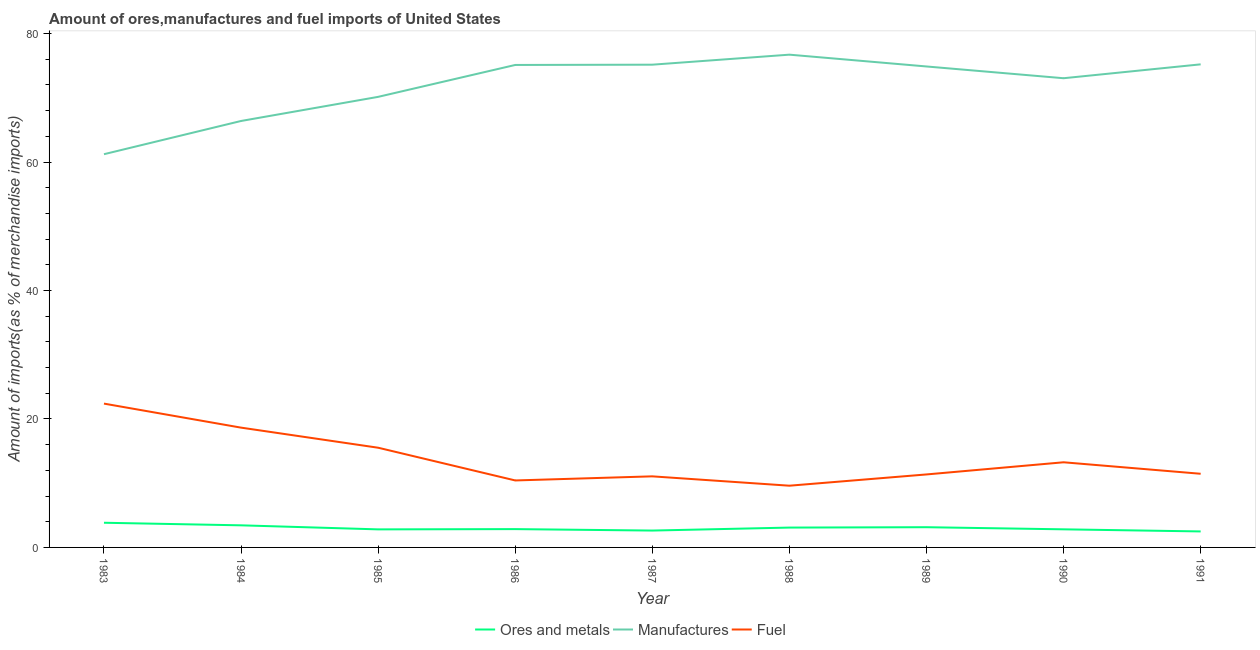What is the percentage of ores and metals imports in 1988?
Ensure brevity in your answer.  3.09. Across all years, what is the maximum percentage of manufactures imports?
Keep it short and to the point. 76.72. Across all years, what is the minimum percentage of fuel imports?
Offer a terse response. 9.61. In which year was the percentage of fuel imports minimum?
Provide a succinct answer. 1988. What is the total percentage of ores and metals imports in the graph?
Provide a succinct answer. 27.12. What is the difference between the percentage of fuel imports in 1984 and that in 1991?
Your response must be concise. 7.18. What is the difference between the percentage of manufactures imports in 1986 and the percentage of ores and metals imports in 1991?
Offer a very short reply. 72.63. What is the average percentage of ores and metals imports per year?
Offer a terse response. 3.01. In the year 1986, what is the difference between the percentage of manufactures imports and percentage of ores and metals imports?
Make the answer very short. 72.26. What is the ratio of the percentage of fuel imports in 1986 to that in 1987?
Keep it short and to the point. 0.94. What is the difference between the highest and the second highest percentage of manufactures imports?
Offer a terse response. 1.51. What is the difference between the highest and the lowest percentage of ores and metals imports?
Your response must be concise. 1.35. Is the percentage of fuel imports strictly greater than the percentage of manufactures imports over the years?
Provide a short and direct response. No. How many lines are there?
Offer a very short reply. 3. Are the values on the major ticks of Y-axis written in scientific E-notation?
Your answer should be compact. No. Does the graph contain grids?
Provide a succinct answer. No. Where does the legend appear in the graph?
Provide a short and direct response. Bottom center. What is the title of the graph?
Keep it short and to the point. Amount of ores,manufactures and fuel imports of United States. Does "Industrial Nitrous Oxide" appear as one of the legend labels in the graph?
Your answer should be very brief. No. What is the label or title of the X-axis?
Offer a very short reply. Year. What is the label or title of the Y-axis?
Your response must be concise. Amount of imports(as % of merchandise imports). What is the Amount of imports(as % of merchandise imports) in Ores and metals in 1983?
Your answer should be compact. 3.84. What is the Amount of imports(as % of merchandise imports) of Manufactures in 1983?
Your response must be concise. 61.22. What is the Amount of imports(as % of merchandise imports) in Fuel in 1983?
Make the answer very short. 22.39. What is the Amount of imports(as % of merchandise imports) of Ores and metals in 1984?
Make the answer very short. 3.44. What is the Amount of imports(as % of merchandise imports) of Manufactures in 1984?
Give a very brief answer. 66.39. What is the Amount of imports(as % of merchandise imports) of Fuel in 1984?
Give a very brief answer. 18.65. What is the Amount of imports(as % of merchandise imports) of Ores and metals in 1985?
Provide a succinct answer. 2.81. What is the Amount of imports(as % of merchandise imports) in Manufactures in 1985?
Your response must be concise. 70.15. What is the Amount of imports(as % of merchandise imports) in Fuel in 1985?
Keep it short and to the point. 15.52. What is the Amount of imports(as % of merchandise imports) in Ores and metals in 1986?
Ensure brevity in your answer.  2.85. What is the Amount of imports(as % of merchandise imports) of Manufactures in 1986?
Make the answer very short. 75.12. What is the Amount of imports(as % of merchandise imports) in Fuel in 1986?
Offer a terse response. 10.43. What is the Amount of imports(as % of merchandise imports) in Ores and metals in 1987?
Provide a succinct answer. 2.63. What is the Amount of imports(as % of merchandise imports) in Manufactures in 1987?
Your answer should be very brief. 75.16. What is the Amount of imports(as % of merchandise imports) of Fuel in 1987?
Ensure brevity in your answer.  11.07. What is the Amount of imports(as % of merchandise imports) of Ores and metals in 1988?
Make the answer very short. 3.09. What is the Amount of imports(as % of merchandise imports) of Manufactures in 1988?
Offer a very short reply. 76.72. What is the Amount of imports(as % of merchandise imports) in Fuel in 1988?
Offer a very short reply. 9.61. What is the Amount of imports(as % of merchandise imports) of Ores and metals in 1989?
Ensure brevity in your answer.  3.15. What is the Amount of imports(as % of merchandise imports) of Manufactures in 1989?
Give a very brief answer. 74.88. What is the Amount of imports(as % of merchandise imports) in Fuel in 1989?
Offer a terse response. 11.36. What is the Amount of imports(as % of merchandise imports) in Ores and metals in 1990?
Provide a short and direct response. 2.82. What is the Amount of imports(as % of merchandise imports) in Manufactures in 1990?
Provide a short and direct response. 73.05. What is the Amount of imports(as % of merchandise imports) of Fuel in 1990?
Offer a very short reply. 13.26. What is the Amount of imports(as % of merchandise imports) in Ores and metals in 1991?
Make the answer very short. 2.49. What is the Amount of imports(as % of merchandise imports) in Manufactures in 1991?
Provide a short and direct response. 75.21. What is the Amount of imports(as % of merchandise imports) in Fuel in 1991?
Provide a short and direct response. 11.47. Across all years, what is the maximum Amount of imports(as % of merchandise imports) of Ores and metals?
Give a very brief answer. 3.84. Across all years, what is the maximum Amount of imports(as % of merchandise imports) of Manufactures?
Offer a very short reply. 76.72. Across all years, what is the maximum Amount of imports(as % of merchandise imports) in Fuel?
Keep it short and to the point. 22.39. Across all years, what is the minimum Amount of imports(as % of merchandise imports) in Ores and metals?
Offer a very short reply. 2.49. Across all years, what is the minimum Amount of imports(as % of merchandise imports) of Manufactures?
Your answer should be compact. 61.22. Across all years, what is the minimum Amount of imports(as % of merchandise imports) in Fuel?
Offer a very short reply. 9.61. What is the total Amount of imports(as % of merchandise imports) in Ores and metals in the graph?
Make the answer very short. 27.12. What is the total Amount of imports(as % of merchandise imports) of Manufactures in the graph?
Keep it short and to the point. 647.9. What is the total Amount of imports(as % of merchandise imports) in Fuel in the graph?
Your response must be concise. 123.75. What is the difference between the Amount of imports(as % of merchandise imports) in Ores and metals in 1983 and that in 1984?
Your answer should be very brief. 0.4. What is the difference between the Amount of imports(as % of merchandise imports) of Manufactures in 1983 and that in 1984?
Ensure brevity in your answer.  -5.17. What is the difference between the Amount of imports(as % of merchandise imports) in Fuel in 1983 and that in 1984?
Provide a short and direct response. 3.74. What is the difference between the Amount of imports(as % of merchandise imports) of Ores and metals in 1983 and that in 1985?
Ensure brevity in your answer.  1.03. What is the difference between the Amount of imports(as % of merchandise imports) in Manufactures in 1983 and that in 1985?
Keep it short and to the point. -8.93. What is the difference between the Amount of imports(as % of merchandise imports) in Fuel in 1983 and that in 1985?
Provide a succinct answer. 6.87. What is the difference between the Amount of imports(as % of merchandise imports) in Ores and metals in 1983 and that in 1986?
Provide a short and direct response. 0.99. What is the difference between the Amount of imports(as % of merchandise imports) in Manufactures in 1983 and that in 1986?
Give a very brief answer. -13.89. What is the difference between the Amount of imports(as % of merchandise imports) in Fuel in 1983 and that in 1986?
Give a very brief answer. 11.96. What is the difference between the Amount of imports(as % of merchandise imports) of Ores and metals in 1983 and that in 1987?
Make the answer very short. 1.21. What is the difference between the Amount of imports(as % of merchandise imports) in Manufactures in 1983 and that in 1987?
Offer a very short reply. -13.94. What is the difference between the Amount of imports(as % of merchandise imports) of Fuel in 1983 and that in 1987?
Make the answer very short. 11.32. What is the difference between the Amount of imports(as % of merchandise imports) of Ores and metals in 1983 and that in 1988?
Offer a very short reply. 0.75. What is the difference between the Amount of imports(as % of merchandise imports) in Manufactures in 1983 and that in 1988?
Offer a very short reply. -15.5. What is the difference between the Amount of imports(as % of merchandise imports) in Fuel in 1983 and that in 1988?
Offer a terse response. 12.78. What is the difference between the Amount of imports(as % of merchandise imports) in Ores and metals in 1983 and that in 1989?
Provide a succinct answer. 0.69. What is the difference between the Amount of imports(as % of merchandise imports) of Manufactures in 1983 and that in 1989?
Your answer should be very brief. -13.66. What is the difference between the Amount of imports(as % of merchandise imports) in Fuel in 1983 and that in 1989?
Provide a short and direct response. 11.03. What is the difference between the Amount of imports(as % of merchandise imports) of Ores and metals in 1983 and that in 1990?
Keep it short and to the point. 1.02. What is the difference between the Amount of imports(as % of merchandise imports) in Manufactures in 1983 and that in 1990?
Provide a short and direct response. -11.83. What is the difference between the Amount of imports(as % of merchandise imports) in Fuel in 1983 and that in 1990?
Offer a very short reply. 9.13. What is the difference between the Amount of imports(as % of merchandise imports) of Ores and metals in 1983 and that in 1991?
Offer a very short reply. 1.35. What is the difference between the Amount of imports(as % of merchandise imports) of Manufactures in 1983 and that in 1991?
Make the answer very short. -13.99. What is the difference between the Amount of imports(as % of merchandise imports) in Fuel in 1983 and that in 1991?
Make the answer very short. 10.92. What is the difference between the Amount of imports(as % of merchandise imports) in Ores and metals in 1984 and that in 1985?
Give a very brief answer. 0.63. What is the difference between the Amount of imports(as % of merchandise imports) of Manufactures in 1984 and that in 1985?
Your answer should be very brief. -3.76. What is the difference between the Amount of imports(as % of merchandise imports) of Fuel in 1984 and that in 1985?
Offer a very short reply. 3.13. What is the difference between the Amount of imports(as % of merchandise imports) in Ores and metals in 1984 and that in 1986?
Ensure brevity in your answer.  0.59. What is the difference between the Amount of imports(as % of merchandise imports) of Manufactures in 1984 and that in 1986?
Provide a short and direct response. -8.72. What is the difference between the Amount of imports(as % of merchandise imports) in Fuel in 1984 and that in 1986?
Offer a very short reply. 8.22. What is the difference between the Amount of imports(as % of merchandise imports) in Ores and metals in 1984 and that in 1987?
Offer a very short reply. 0.81. What is the difference between the Amount of imports(as % of merchandise imports) in Manufactures in 1984 and that in 1987?
Your answer should be compact. -8.76. What is the difference between the Amount of imports(as % of merchandise imports) in Fuel in 1984 and that in 1987?
Provide a short and direct response. 7.58. What is the difference between the Amount of imports(as % of merchandise imports) of Ores and metals in 1984 and that in 1988?
Provide a short and direct response. 0.35. What is the difference between the Amount of imports(as % of merchandise imports) in Manufactures in 1984 and that in 1988?
Your answer should be compact. -10.32. What is the difference between the Amount of imports(as % of merchandise imports) of Fuel in 1984 and that in 1988?
Your answer should be compact. 9.04. What is the difference between the Amount of imports(as % of merchandise imports) of Ores and metals in 1984 and that in 1989?
Your answer should be very brief. 0.29. What is the difference between the Amount of imports(as % of merchandise imports) of Manufactures in 1984 and that in 1989?
Your answer should be compact. -8.49. What is the difference between the Amount of imports(as % of merchandise imports) of Fuel in 1984 and that in 1989?
Offer a very short reply. 7.29. What is the difference between the Amount of imports(as % of merchandise imports) in Ores and metals in 1984 and that in 1990?
Give a very brief answer. 0.62. What is the difference between the Amount of imports(as % of merchandise imports) in Manufactures in 1984 and that in 1990?
Your answer should be very brief. -6.66. What is the difference between the Amount of imports(as % of merchandise imports) of Fuel in 1984 and that in 1990?
Provide a short and direct response. 5.39. What is the difference between the Amount of imports(as % of merchandise imports) in Ores and metals in 1984 and that in 1991?
Provide a succinct answer. 0.95. What is the difference between the Amount of imports(as % of merchandise imports) in Manufactures in 1984 and that in 1991?
Offer a terse response. -8.82. What is the difference between the Amount of imports(as % of merchandise imports) of Fuel in 1984 and that in 1991?
Provide a succinct answer. 7.18. What is the difference between the Amount of imports(as % of merchandise imports) in Ores and metals in 1985 and that in 1986?
Offer a terse response. -0.04. What is the difference between the Amount of imports(as % of merchandise imports) in Manufactures in 1985 and that in 1986?
Make the answer very short. -4.97. What is the difference between the Amount of imports(as % of merchandise imports) in Fuel in 1985 and that in 1986?
Your response must be concise. 5.1. What is the difference between the Amount of imports(as % of merchandise imports) in Ores and metals in 1985 and that in 1987?
Provide a short and direct response. 0.19. What is the difference between the Amount of imports(as % of merchandise imports) of Manufactures in 1985 and that in 1987?
Provide a succinct answer. -5.01. What is the difference between the Amount of imports(as % of merchandise imports) in Fuel in 1985 and that in 1987?
Your answer should be very brief. 4.46. What is the difference between the Amount of imports(as % of merchandise imports) of Ores and metals in 1985 and that in 1988?
Provide a succinct answer. -0.28. What is the difference between the Amount of imports(as % of merchandise imports) of Manufactures in 1985 and that in 1988?
Your answer should be compact. -6.57. What is the difference between the Amount of imports(as % of merchandise imports) of Fuel in 1985 and that in 1988?
Offer a terse response. 5.91. What is the difference between the Amount of imports(as % of merchandise imports) of Ores and metals in 1985 and that in 1989?
Keep it short and to the point. -0.34. What is the difference between the Amount of imports(as % of merchandise imports) of Manufactures in 1985 and that in 1989?
Offer a very short reply. -4.73. What is the difference between the Amount of imports(as % of merchandise imports) of Fuel in 1985 and that in 1989?
Your answer should be very brief. 4.16. What is the difference between the Amount of imports(as % of merchandise imports) of Ores and metals in 1985 and that in 1990?
Ensure brevity in your answer.  -0.01. What is the difference between the Amount of imports(as % of merchandise imports) in Manufactures in 1985 and that in 1990?
Offer a terse response. -2.9. What is the difference between the Amount of imports(as % of merchandise imports) in Fuel in 1985 and that in 1990?
Your answer should be compact. 2.27. What is the difference between the Amount of imports(as % of merchandise imports) of Ores and metals in 1985 and that in 1991?
Make the answer very short. 0.32. What is the difference between the Amount of imports(as % of merchandise imports) in Manufactures in 1985 and that in 1991?
Provide a succinct answer. -5.06. What is the difference between the Amount of imports(as % of merchandise imports) in Fuel in 1985 and that in 1991?
Your response must be concise. 4.06. What is the difference between the Amount of imports(as % of merchandise imports) of Ores and metals in 1986 and that in 1987?
Offer a very short reply. 0.23. What is the difference between the Amount of imports(as % of merchandise imports) in Manufactures in 1986 and that in 1987?
Give a very brief answer. -0.04. What is the difference between the Amount of imports(as % of merchandise imports) in Fuel in 1986 and that in 1987?
Offer a terse response. -0.64. What is the difference between the Amount of imports(as % of merchandise imports) of Ores and metals in 1986 and that in 1988?
Your answer should be very brief. -0.24. What is the difference between the Amount of imports(as % of merchandise imports) of Manufactures in 1986 and that in 1988?
Keep it short and to the point. -1.6. What is the difference between the Amount of imports(as % of merchandise imports) in Fuel in 1986 and that in 1988?
Your response must be concise. 0.82. What is the difference between the Amount of imports(as % of merchandise imports) in Ores and metals in 1986 and that in 1989?
Offer a terse response. -0.3. What is the difference between the Amount of imports(as % of merchandise imports) of Manufactures in 1986 and that in 1989?
Ensure brevity in your answer.  0.24. What is the difference between the Amount of imports(as % of merchandise imports) in Fuel in 1986 and that in 1989?
Offer a very short reply. -0.94. What is the difference between the Amount of imports(as % of merchandise imports) in Ores and metals in 1986 and that in 1990?
Give a very brief answer. 0.03. What is the difference between the Amount of imports(as % of merchandise imports) of Manufactures in 1986 and that in 1990?
Provide a succinct answer. 2.07. What is the difference between the Amount of imports(as % of merchandise imports) in Fuel in 1986 and that in 1990?
Offer a terse response. -2.83. What is the difference between the Amount of imports(as % of merchandise imports) of Ores and metals in 1986 and that in 1991?
Offer a very short reply. 0.36. What is the difference between the Amount of imports(as % of merchandise imports) in Manufactures in 1986 and that in 1991?
Keep it short and to the point. -0.1. What is the difference between the Amount of imports(as % of merchandise imports) in Fuel in 1986 and that in 1991?
Offer a terse response. -1.04. What is the difference between the Amount of imports(as % of merchandise imports) in Ores and metals in 1987 and that in 1988?
Provide a succinct answer. -0.46. What is the difference between the Amount of imports(as % of merchandise imports) of Manufactures in 1987 and that in 1988?
Your answer should be very brief. -1.56. What is the difference between the Amount of imports(as % of merchandise imports) in Fuel in 1987 and that in 1988?
Offer a terse response. 1.46. What is the difference between the Amount of imports(as % of merchandise imports) in Ores and metals in 1987 and that in 1989?
Keep it short and to the point. -0.52. What is the difference between the Amount of imports(as % of merchandise imports) in Manufactures in 1987 and that in 1989?
Your response must be concise. 0.28. What is the difference between the Amount of imports(as % of merchandise imports) in Fuel in 1987 and that in 1989?
Ensure brevity in your answer.  -0.3. What is the difference between the Amount of imports(as % of merchandise imports) in Ores and metals in 1987 and that in 1990?
Ensure brevity in your answer.  -0.19. What is the difference between the Amount of imports(as % of merchandise imports) of Manufactures in 1987 and that in 1990?
Your answer should be compact. 2.11. What is the difference between the Amount of imports(as % of merchandise imports) in Fuel in 1987 and that in 1990?
Offer a very short reply. -2.19. What is the difference between the Amount of imports(as % of merchandise imports) of Ores and metals in 1987 and that in 1991?
Offer a very short reply. 0.14. What is the difference between the Amount of imports(as % of merchandise imports) in Manufactures in 1987 and that in 1991?
Your answer should be compact. -0.05. What is the difference between the Amount of imports(as % of merchandise imports) of Fuel in 1987 and that in 1991?
Provide a short and direct response. -0.4. What is the difference between the Amount of imports(as % of merchandise imports) in Ores and metals in 1988 and that in 1989?
Give a very brief answer. -0.06. What is the difference between the Amount of imports(as % of merchandise imports) of Manufactures in 1988 and that in 1989?
Provide a short and direct response. 1.84. What is the difference between the Amount of imports(as % of merchandise imports) in Fuel in 1988 and that in 1989?
Your response must be concise. -1.75. What is the difference between the Amount of imports(as % of merchandise imports) in Ores and metals in 1988 and that in 1990?
Keep it short and to the point. 0.27. What is the difference between the Amount of imports(as % of merchandise imports) in Manufactures in 1988 and that in 1990?
Your answer should be compact. 3.67. What is the difference between the Amount of imports(as % of merchandise imports) in Fuel in 1988 and that in 1990?
Offer a very short reply. -3.65. What is the difference between the Amount of imports(as % of merchandise imports) of Ores and metals in 1988 and that in 1991?
Your answer should be compact. 0.6. What is the difference between the Amount of imports(as % of merchandise imports) of Manufactures in 1988 and that in 1991?
Give a very brief answer. 1.51. What is the difference between the Amount of imports(as % of merchandise imports) of Fuel in 1988 and that in 1991?
Provide a succinct answer. -1.86. What is the difference between the Amount of imports(as % of merchandise imports) of Ores and metals in 1989 and that in 1990?
Your response must be concise. 0.33. What is the difference between the Amount of imports(as % of merchandise imports) of Manufactures in 1989 and that in 1990?
Make the answer very short. 1.83. What is the difference between the Amount of imports(as % of merchandise imports) of Fuel in 1989 and that in 1990?
Make the answer very short. -1.89. What is the difference between the Amount of imports(as % of merchandise imports) of Ores and metals in 1989 and that in 1991?
Offer a terse response. 0.66. What is the difference between the Amount of imports(as % of merchandise imports) in Manufactures in 1989 and that in 1991?
Ensure brevity in your answer.  -0.33. What is the difference between the Amount of imports(as % of merchandise imports) in Fuel in 1989 and that in 1991?
Give a very brief answer. -0.1. What is the difference between the Amount of imports(as % of merchandise imports) of Ores and metals in 1990 and that in 1991?
Offer a very short reply. 0.33. What is the difference between the Amount of imports(as % of merchandise imports) of Manufactures in 1990 and that in 1991?
Your answer should be very brief. -2.16. What is the difference between the Amount of imports(as % of merchandise imports) in Fuel in 1990 and that in 1991?
Your answer should be very brief. 1.79. What is the difference between the Amount of imports(as % of merchandise imports) of Ores and metals in 1983 and the Amount of imports(as % of merchandise imports) of Manufactures in 1984?
Your answer should be compact. -62.55. What is the difference between the Amount of imports(as % of merchandise imports) of Ores and metals in 1983 and the Amount of imports(as % of merchandise imports) of Fuel in 1984?
Give a very brief answer. -14.81. What is the difference between the Amount of imports(as % of merchandise imports) in Manufactures in 1983 and the Amount of imports(as % of merchandise imports) in Fuel in 1984?
Offer a very short reply. 42.57. What is the difference between the Amount of imports(as % of merchandise imports) in Ores and metals in 1983 and the Amount of imports(as % of merchandise imports) in Manufactures in 1985?
Offer a terse response. -66.31. What is the difference between the Amount of imports(as % of merchandise imports) of Ores and metals in 1983 and the Amount of imports(as % of merchandise imports) of Fuel in 1985?
Ensure brevity in your answer.  -11.68. What is the difference between the Amount of imports(as % of merchandise imports) of Manufactures in 1983 and the Amount of imports(as % of merchandise imports) of Fuel in 1985?
Your response must be concise. 45.7. What is the difference between the Amount of imports(as % of merchandise imports) in Ores and metals in 1983 and the Amount of imports(as % of merchandise imports) in Manufactures in 1986?
Your answer should be very brief. -71.28. What is the difference between the Amount of imports(as % of merchandise imports) in Ores and metals in 1983 and the Amount of imports(as % of merchandise imports) in Fuel in 1986?
Your response must be concise. -6.59. What is the difference between the Amount of imports(as % of merchandise imports) of Manufactures in 1983 and the Amount of imports(as % of merchandise imports) of Fuel in 1986?
Ensure brevity in your answer.  50.79. What is the difference between the Amount of imports(as % of merchandise imports) of Ores and metals in 1983 and the Amount of imports(as % of merchandise imports) of Manufactures in 1987?
Provide a short and direct response. -71.32. What is the difference between the Amount of imports(as % of merchandise imports) of Ores and metals in 1983 and the Amount of imports(as % of merchandise imports) of Fuel in 1987?
Make the answer very short. -7.22. What is the difference between the Amount of imports(as % of merchandise imports) of Manufactures in 1983 and the Amount of imports(as % of merchandise imports) of Fuel in 1987?
Your response must be concise. 50.16. What is the difference between the Amount of imports(as % of merchandise imports) in Ores and metals in 1983 and the Amount of imports(as % of merchandise imports) in Manufactures in 1988?
Give a very brief answer. -72.88. What is the difference between the Amount of imports(as % of merchandise imports) in Ores and metals in 1983 and the Amount of imports(as % of merchandise imports) in Fuel in 1988?
Make the answer very short. -5.77. What is the difference between the Amount of imports(as % of merchandise imports) of Manufactures in 1983 and the Amount of imports(as % of merchandise imports) of Fuel in 1988?
Your response must be concise. 51.61. What is the difference between the Amount of imports(as % of merchandise imports) in Ores and metals in 1983 and the Amount of imports(as % of merchandise imports) in Manufactures in 1989?
Offer a very short reply. -71.04. What is the difference between the Amount of imports(as % of merchandise imports) in Ores and metals in 1983 and the Amount of imports(as % of merchandise imports) in Fuel in 1989?
Make the answer very short. -7.52. What is the difference between the Amount of imports(as % of merchandise imports) in Manufactures in 1983 and the Amount of imports(as % of merchandise imports) in Fuel in 1989?
Keep it short and to the point. 49.86. What is the difference between the Amount of imports(as % of merchandise imports) of Ores and metals in 1983 and the Amount of imports(as % of merchandise imports) of Manufactures in 1990?
Offer a very short reply. -69.21. What is the difference between the Amount of imports(as % of merchandise imports) of Ores and metals in 1983 and the Amount of imports(as % of merchandise imports) of Fuel in 1990?
Offer a very short reply. -9.42. What is the difference between the Amount of imports(as % of merchandise imports) of Manufactures in 1983 and the Amount of imports(as % of merchandise imports) of Fuel in 1990?
Keep it short and to the point. 47.96. What is the difference between the Amount of imports(as % of merchandise imports) of Ores and metals in 1983 and the Amount of imports(as % of merchandise imports) of Manufactures in 1991?
Your answer should be very brief. -71.37. What is the difference between the Amount of imports(as % of merchandise imports) in Ores and metals in 1983 and the Amount of imports(as % of merchandise imports) in Fuel in 1991?
Your answer should be compact. -7.63. What is the difference between the Amount of imports(as % of merchandise imports) of Manufactures in 1983 and the Amount of imports(as % of merchandise imports) of Fuel in 1991?
Give a very brief answer. 49.75. What is the difference between the Amount of imports(as % of merchandise imports) of Ores and metals in 1984 and the Amount of imports(as % of merchandise imports) of Manufactures in 1985?
Your answer should be compact. -66.71. What is the difference between the Amount of imports(as % of merchandise imports) in Ores and metals in 1984 and the Amount of imports(as % of merchandise imports) in Fuel in 1985?
Give a very brief answer. -12.08. What is the difference between the Amount of imports(as % of merchandise imports) in Manufactures in 1984 and the Amount of imports(as % of merchandise imports) in Fuel in 1985?
Your answer should be compact. 50.87. What is the difference between the Amount of imports(as % of merchandise imports) of Ores and metals in 1984 and the Amount of imports(as % of merchandise imports) of Manufactures in 1986?
Offer a very short reply. -71.68. What is the difference between the Amount of imports(as % of merchandise imports) in Ores and metals in 1984 and the Amount of imports(as % of merchandise imports) in Fuel in 1986?
Ensure brevity in your answer.  -6.99. What is the difference between the Amount of imports(as % of merchandise imports) of Manufactures in 1984 and the Amount of imports(as % of merchandise imports) of Fuel in 1986?
Give a very brief answer. 55.97. What is the difference between the Amount of imports(as % of merchandise imports) in Ores and metals in 1984 and the Amount of imports(as % of merchandise imports) in Manufactures in 1987?
Offer a terse response. -71.72. What is the difference between the Amount of imports(as % of merchandise imports) of Ores and metals in 1984 and the Amount of imports(as % of merchandise imports) of Fuel in 1987?
Make the answer very short. -7.63. What is the difference between the Amount of imports(as % of merchandise imports) of Manufactures in 1984 and the Amount of imports(as % of merchandise imports) of Fuel in 1987?
Ensure brevity in your answer.  55.33. What is the difference between the Amount of imports(as % of merchandise imports) of Ores and metals in 1984 and the Amount of imports(as % of merchandise imports) of Manufactures in 1988?
Provide a succinct answer. -73.28. What is the difference between the Amount of imports(as % of merchandise imports) in Ores and metals in 1984 and the Amount of imports(as % of merchandise imports) in Fuel in 1988?
Offer a very short reply. -6.17. What is the difference between the Amount of imports(as % of merchandise imports) in Manufactures in 1984 and the Amount of imports(as % of merchandise imports) in Fuel in 1988?
Give a very brief answer. 56.78. What is the difference between the Amount of imports(as % of merchandise imports) in Ores and metals in 1984 and the Amount of imports(as % of merchandise imports) in Manufactures in 1989?
Give a very brief answer. -71.44. What is the difference between the Amount of imports(as % of merchandise imports) of Ores and metals in 1984 and the Amount of imports(as % of merchandise imports) of Fuel in 1989?
Offer a very short reply. -7.92. What is the difference between the Amount of imports(as % of merchandise imports) in Manufactures in 1984 and the Amount of imports(as % of merchandise imports) in Fuel in 1989?
Keep it short and to the point. 55.03. What is the difference between the Amount of imports(as % of merchandise imports) of Ores and metals in 1984 and the Amount of imports(as % of merchandise imports) of Manufactures in 1990?
Ensure brevity in your answer.  -69.61. What is the difference between the Amount of imports(as % of merchandise imports) of Ores and metals in 1984 and the Amount of imports(as % of merchandise imports) of Fuel in 1990?
Provide a short and direct response. -9.82. What is the difference between the Amount of imports(as % of merchandise imports) in Manufactures in 1984 and the Amount of imports(as % of merchandise imports) in Fuel in 1990?
Make the answer very short. 53.14. What is the difference between the Amount of imports(as % of merchandise imports) of Ores and metals in 1984 and the Amount of imports(as % of merchandise imports) of Manufactures in 1991?
Keep it short and to the point. -71.77. What is the difference between the Amount of imports(as % of merchandise imports) in Ores and metals in 1984 and the Amount of imports(as % of merchandise imports) in Fuel in 1991?
Ensure brevity in your answer.  -8.03. What is the difference between the Amount of imports(as % of merchandise imports) of Manufactures in 1984 and the Amount of imports(as % of merchandise imports) of Fuel in 1991?
Ensure brevity in your answer.  54.93. What is the difference between the Amount of imports(as % of merchandise imports) of Ores and metals in 1985 and the Amount of imports(as % of merchandise imports) of Manufactures in 1986?
Your response must be concise. -72.3. What is the difference between the Amount of imports(as % of merchandise imports) in Ores and metals in 1985 and the Amount of imports(as % of merchandise imports) in Fuel in 1986?
Your answer should be compact. -7.62. What is the difference between the Amount of imports(as % of merchandise imports) in Manufactures in 1985 and the Amount of imports(as % of merchandise imports) in Fuel in 1986?
Offer a very short reply. 59.72. What is the difference between the Amount of imports(as % of merchandise imports) in Ores and metals in 1985 and the Amount of imports(as % of merchandise imports) in Manufactures in 1987?
Your response must be concise. -72.35. What is the difference between the Amount of imports(as % of merchandise imports) in Ores and metals in 1985 and the Amount of imports(as % of merchandise imports) in Fuel in 1987?
Keep it short and to the point. -8.25. What is the difference between the Amount of imports(as % of merchandise imports) of Manufactures in 1985 and the Amount of imports(as % of merchandise imports) of Fuel in 1987?
Provide a short and direct response. 59.08. What is the difference between the Amount of imports(as % of merchandise imports) in Ores and metals in 1985 and the Amount of imports(as % of merchandise imports) in Manufactures in 1988?
Offer a very short reply. -73.91. What is the difference between the Amount of imports(as % of merchandise imports) in Ores and metals in 1985 and the Amount of imports(as % of merchandise imports) in Fuel in 1988?
Offer a very short reply. -6.8. What is the difference between the Amount of imports(as % of merchandise imports) in Manufactures in 1985 and the Amount of imports(as % of merchandise imports) in Fuel in 1988?
Your response must be concise. 60.54. What is the difference between the Amount of imports(as % of merchandise imports) of Ores and metals in 1985 and the Amount of imports(as % of merchandise imports) of Manufactures in 1989?
Offer a terse response. -72.07. What is the difference between the Amount of imports(as % of merchandise imports) in Ores and metals in 1985 and the Amount of imports(as % of merchandise imports) in Fuel in 1989?
Your answer should be very brief. -8.55. What is the difference between the Amount of imports(as % of merchandise imports) in Manufactures in 1985 and the Amount of imports(as % of merchandise imports) in Fuel in 1989?
Provide a short and direct response. 58.79. What is the difference between the Amount of imports(as % of merchandise imports) of Ores and metals in 1985 and the Amount of imports(as % of merchandise imports) of Manufactures in 1990?
Offer a terse response. -70.24. What is the difference between the Amount of imports(as % of merchandise imports) in Ores and metals in 1985 and the Amount of imports(as % of merchandise imports) in Fuel in 1990?
Make the answer very short. -10.45. What is the difference between the Amount of imports(as % of merchandise imports) in Manufactures in 1985 and the Amount of imports(as % of merchandise imports) in Fuel in 1990?
Provide a succinct answer. 56.89. What is the difference between the Amount of imports(as % of merchandise imports) of Ores and metals in 1985 and the Amount of imports(as % of merchandise imports) of Manufactures in 1991?
Keep it short and to the point. -72.4. What is the difference between the Amount of imports(as % of merchandise imports) of Ores and metals in 1985 and the Amount of imports(as % of merchandise imports) of Fuel in 1991?
Offer a very short reply. -8.66. What is the difference between the Amount of imports(as % of merchandise imports) in Manufactures in 1985 and the Amount of imports(as % of merchandise imports) in Fuel in 1991?
Ensure brevity in your answer.  58.68. What is the difference between the Amount of imports(as % of merchandise imports) of Ores and metals in 1986 and the Amount of imports(as % of merchandise imports) of Manufactures in 1987?
Give a very brief answer. -72.31. What is the difference between the Amount of imports(as % of merchandise imports) of Ores and metals in 1986 and the Amount of imports(as % of merchandise imports) of Fuel in 1987?
Make the answer very short. -8.21. What is the difference between the Amount of imports(as % of merchandise imports) in Manufactures in 1986 and the Amount of imports(as % of merchandise imports) in Fuel in 1987?
Provide a succinct answer. 64.05. What is the difference between the Amount of imports(as % of merchandise imports) in Ores and metals in 1986 and the Amount of imports(as % of merchandise imports) in Manufactures in 1988?
Provide a succinct answer. -73.87. What is the difference between the Amount of imports(as % of merchandise imports) in Ores and metals in 1986 and the Amount of imports(as % of merchandise imports) in Fuel in 1988?
Your answer should be compact. -6.76. What is the difference between the Amount of imports(as % of merchandise imports) in Manufactures in 1986 and the Amount of imports(as % of merchandise imports) in Fuel in 1988?
Give a very brief answer. 65.51. What is the difference between the Amount of imports(as % of merchandise imports) of Ores and metals in 1986 and the Amount of imports(as % of merchandise imports) of Manufactures in 1989?
Your answer should be very brief. -72.03. What is the difference between the Amount of imports(as % of merchandise imports) of Ores and metals in 1986 and the Amount of imports(as % of merchandise imports) of Fuel in 1989?
Give a very brief answer. -8.51. What is the difference between the Amount of imports(as % of merchandise imports) in Manufactures in 1986 and the Amount of imports(as % of merchandise imports) in Fuel in 1989?
Offer a terse response. 63.75. What is the difference between the Amount of imports(as % of merchandise imports) in Ores and metals in 1986 and the Amount of imports(as % of merchandise imports) in Manufactures in 1990?
Make the answer very short. -70.2. What is the difference between the Amount of imports(as % of merchandise imports) of Ores and metals in 1986 and the Amount of imports(as % of merchandise imports) of Fuel in 1990?
Offer a terse response. -10.4. What is the difference between the Amount of imports(as % of merchandise imports) in Manufactures in 1986 and the Amount of imports(as % of merchandise imports) in Fuel in 1990?
Your answer should be compact. 61.86. What is the difference between the Amount of imports(as % of merchandise imports) of Ores and metals in 1986 and the Amount of imports(as % of merchandise imports) of Manufactures in 1991?
Give a very brief answer. -72.36. What is the difference between the Amount of imports(as % of merchandise imports) of Ores and metals in 1986 and the Amount of imports(as % of merchandise imports) of Fuel in 1991?
Your answer should be compact. -8.61. What is the difference between the Amount of imports(as % of merchandise imports) in Manufactures in 1986 and the Amount of imports(as % of merchandise imports) in Fuel in 1991?
Your response must be concise. 63.65. What is the difference between the Amount of imports(as % of merchandise imports) of Ores and metals in 1987 and the Amount of imports(as % of merchandise imports) of Manufactures in 1988?
Keep it short and to the point. -74.09. What is the difference between the Amount of imports(as % of merchandise imports) in Ores and metals in 1987 and the Amount of imports(as % of merchandise imports) in Fuel in 1988?
Ensure brevity in your answer.  -6.98. What is the difference between the Amount of imports(as % of merchandise imports) of Manufactures in 1987 and the Amount of imports(as % of merchandise imports) of Fuel in 1988?
Give a very brief answer. 65.55. What is the difference between the Amount of imports(as % of merchandise imports) of Ores and metals in 1987 and the Amount of imports(as % of merchandise imports) of Manufactures in 1989?
Your answer should be very brief. -72.25. What is the difference between the Amount of imports(as % of merchandise imports) in Ores and metals in 1987 and the Amount of imports(as % of merchandise imports) in Fuel in 1989?
Offer a very short reply. -8.74. What is the difference between the Amount of imports(as % of merchandise imports) in Manufactures in 1987 and the Amount of imports(as % of merchandise imports) in Fuel in 1989?
Provide a succinct answer. 63.8. What is the difference between the Amount of imports(as % of merchandise imports) of Ores and metals in 1987 and the Amount of imports(as % of merchandise imports) of Manufactures in 1990?
Make the answer very short. -70.42. What is the difference between the Amount of imports(as % of merchandise imports) of Ores and metals in 1987 and the Amount of imports(as % of merchandise imports) of Fuel in 1990?
Provide a short and direct response. -10.63. What is the difference between the Amount of imports(as % of merchandise imports) of Manufactures in 1987 and the Amount of imports(as % of merchandise imports) of Fuel in 1990?
Your answer should be very brief. 61.9. What is the difference between the Amount of imports(as % of merchandise imports) in Ores and metals in 1987 and the Amount of imports(as % of merchandise imports) in Manufactures in 1991?
Your response must be concise. -72.59. What is the difference between the Amount of imports(as % of merchandise imports) in Ores and metals in 1987 and the Amount of imports(as % of merchandise imports) in Fuel in 1991?
Provide a succinct answer. -8.84. What is the difference between the Amount of imports(as % of merchandise imports) in Manufactures in 1987 and the Amount of imports(as % of merchandise imports) in Fuel in 1991?
Make the answer very short. 63.69. What is the difference between the Amount of imports(as % of merchandise imports) of Ores and metals in 1988 and the Amount of imports(as % of merchandise imports) of Manufactures in 1989?
Your answer should be compact. -71.79. What is the difference between the Amount of imports(as % of merchandise imports) of Ores and metals in 1988 and the Amount of imports(as % of merchandise imports) of Fuel in 1989?
Your response must be concise. -8.27. What is the difference between the Amount of imports(as % of merchandise imports) in Manufactures in 1988 and the Amount of imports(as % of merchandise imports) in Fuel in 1989?
Provide a short and direct response. 65.36. What is the difference between the Amount of imports(as % of merchandise imports) in Ores and metals in 1988 and the Amount of imports(as % of merchandise imports) in Manufactures in 1990?
Keep it short and to the point. -69.96. What is the difference between the Amount of imports(as % of merchandise imports) of Ores and metals in 1988 and the Amount of imports(as % of merchandise imports) of Fuel in 1990?
Give a very brief answer. -10.17. What is the difference between the Amount of imports(as % of merchandise imports) in Manufactures in 1988 and the Amount of imports(as % of merchandise imports) in Fuel in 1990?
Give a very brief answer. 63.46. What is the difference between the Amount of imports(as % of merchandise imports) in Ores and metals in 1988 and the Amount of imports(as % of merchandise imports) in Manufactures in 1991?
Ensure brevity in your answer.  -72.12. What is the difference between the Amount of imports(as % of merchandise imports) of Ores and metals in 1988 and the Amount of imports(as % of merchandise imports) of Fuel in 1991?
Your answer should be very brief. -8.38. What is the difference between the Amount of imports(as % of merchandise imports) in Manufactures in 1988 and the Amount of imports(as % of merchandise imports) in Fuel in 1991?
Ensure brevity in your answer.  65.25. What is the difference between the Amount of imports(as % of merchandise imports) of Ores and metals in 1989 and the Amount of imports(as % of merchandise imports) of Manufactures in 1990?
Keep it short and to the point. -69.9. What is the difference between the Amount of imports(as % of merchandise imports) of Ores and metals in 1989 and the Amount of imports(as % of merchandise imports) of Fuel in 1990?
Provide a short and direct response. -10.11. What is the difference between the Amount of imports(as % of merchandise imports) of Manufactures in 1989 and the Amount of imports(as % of merchandise imports) of Fuel in 1990?
Provide a short and direct response. 61.62. What is the difference between the Amount of imports(as % of merchandise imports) of Ores and metals in 1989 and the Amount of imports(as % of merchandise imports) of Manufactures in 1991?
Give a very brief answer. -72.06. What is the difference between the Amount of imports(as % of merchandise imports) of Ores and metals in 1989 and the Amount of imports(as % of merchandise imports) of Fuel in 1991?
Give a very brief answer. -8.32. What is the difference between the Amount of imports(as % of merchandise imports) of Manufactures in 1989 and the Amount of imports(as % of merchandise imports) of Fuel in 1991?
Ensure brevity in your answer.  63.41. What is the difference between the Amount of imports(as % of merchandise imports) in Ores and metals in 1990 and the Amount of imports(as % of merchandise imports) in Manufactures in 1991?
Ensure brevity in your answer.  -72.39. What is the difference between the Amount of imports(as % of merchandise imports) of Ores and metals in 1990 and the Amount of imports(as % of merchandise imports) of Fuel in 1991?
Your answer should be very brief. -8.65. What is the difference between the Amount of imports(as % of merchandise imports) of Manufactures in 1990 and the Amount of imports(as % of merchandise imports) of Fuel in 1991?
Provide a short and direct response. 61.58. What is the average Amount of imports(as % of merchandise imports) in Ores and metals per year?
Keep it short and to the point. 3.01. What is the average Amount of imports(as % of merchandise imports) of Manufactures per year?
Your response must be concise. 71.99. What is the average Amount of imports(as % of merchandise imports) of Fuel per year?
Provide a succinct answer. 13.75. In the year 1983, what is the difference between the Amount of imports(as % of merchandise imports) in Ores and metals and Amount of imports(as % of merchandise imports) in Manufactures?
Offer a terse response. -57.38. In the year 1983, what is the difference between the Amount of imports(as % of merchandise imports) of Ores and metals and Amount of imports(as % of merchandise imports) of Fuel?
Ensure brevity in your answer.  -18.55. In the year 1983, what is the difference between the Amount of imports(as % of merchandise imports) in Manufactures and Amount of imports(as % of merchandise imports) in Fuel?
Your answer should be compact. 38.83. In the year 1984, what is the difference between the Amount of imports(as % of merchandise imports) in Ores and metals and Amount of imports(as % of merchandise imports) in Manufactures?
Keep it short and to the point. -62.95. In the year 1984, what is the difference between the Amount of imports(as % of merchandise imports) of Ores and metals and Amount of imports(as % of merchandise imports) of Fuel?
Provide a succinct answer. -15.21. In the year 1984, what is the difference between the Amount of imports(as % of merchandise imports) in Manufactures and Amount of imports(as % of merchandise imports) in Fuel?
Make the answer very short. 47.74. In the year 1985, what is the difference between the Amount of imports(as % of merchandise imports) in Ores and metals and Amount of imports(as % of merchandise imports) in Manufactures?
Give a very brief answer. -67.34. In the year 1985, what is the difference between the Amount of imports(as % of merchandise imports) of Ores and metals and Amount of imports(as % of merchandise imports) of Fuel?
Keep it short and to the point. -12.71. In the year 1985, what is the difference between the Amount of imports(as % of merchandise imports) of Manufactures and Amount of imports(as % of merchandise imports) of Fuel?
Offer a very short reply. 54.63. In the year 1986, what is the difference between the Amount of imports(as % of merchandise imports) in Ores and metals and Amount of imports(as % of merchandise imports) in Manufactures?
Keep it short and to the point. -72.26. In the year 1986, what is the difference between the Amount of imports(as % of merchandise imports) of Ores and metals and Amount of imports(as % of merchandise imports) of Fuel?
Make the answer very short. -7.58. In the year 1986, what is the difference between the Amount of imports(as % of merchandise imports) of Manufactures and Amount of imports(as % of merchandise imports) of Fuel?
Make the answer very short. 64.69. In the year 1987, what is the difference between the Amount of imports(as % of merchandise imports) of Ores and metals and Amount of imports(as % of merchandise imports) of Manufactures?
Provide a succinct answer. -72.53. In the year 1987, what is the difference between the Amount of imports(as % of merchandise imports) in Ores and metals and Amount of imports(as % of merchandise imports) in Fuel?
Provide a short and direct response. -8.44. In the year 1987, what is the difference between the Amount of imports(as % of merchandise imports) in Manufactures and Amount of imports(as % of merchandise imports) in Fuel?
Ensure brevity in your answer.  64.09. In the year 1988, what is the difference between the Amount of imports(as % of merchandise imports) of Ores and metals and Amount of imports(as % of merchandise imports) of Manufactures?
Your answer should be compact. -73.63. In the year 1988, what is the difference between the Amount of imports(as % of merchandise imports) of Ores and metals and Amount of imports(as % of merchandise imports) of Fuel?
Your response must be concise. -6.52. In the year 1988, what is the difference between the Amount of imports(as % of merchandise imports) of Manufactures and Amount of imports(as % of merchandise imports) of Fuel?
Provide a short and direct response. 67.11. In the year 1989, what is the difference between the Amount of imports(as % of merchandise imports) in Ores and metals and Amount of imports(as % of merchandise imports) in Manufactures?
Provide a short and direct response. -71.73. In the year 1989, what is the difference between the Amount of imports(as % of merchandise imports) in Ores and metals and Amount of imports(as % of merchandise imports) in Fuel?
Keep it short and to the point. -8.21. In the year 1989, what is the difference between the Amount of imports(as % of merchandise imports) of Manufactures and Amount of imports(as % of merchandise imports) of Fuel?
Ensure brevity in your answer.  63.52. In the year 1990, what is the difference between the Amount of imports(as % of merchandise imports) in Ores and metals and Amount of imports(as % of merchandise imports) in Manufactures?
Provide a succinct answer. -70.23. In the year 1990, what is the difference between the Amount of imports(as % of merchandise imports) of Ores and metals and Amount of imports(as % of merchandise imports) of Fuel?
Ensure brevity in your answer.  -10.44. In the year 1990, what is the difference between the Amount of imports(as % of merchandise imports) in Manufactures and Amount of imports(as % of merchandise imports) in Fuel?
Provide a succinct answer. 59.79. In the year 1991, what is the difference between the Amount of imports(as % of merchandise imports) of Ores and metals and Amount of imports(as % of merchandise imports) of Manufactures?
Your answer should be very brief. -72.72. In the year 1991, what is the difference between the Amount of imports(as % of merchandise imports) in Ores and metals and Amount of imports(as % of merchandise imports) in Fuel?
Ensure brevity in your answer.  -8.98. In the year 1991, what is the difference between the Amount of imports(as % of merchandise imports) of Manufactures and Amount of imports(as % of merchandise imports) of Fuel?
Offer a terse response. 63.74. What is the ratio of the Amount of imports(as % of merchandise imports) in Ores and metals in 1983 to that in 1984?
Give a very brief answer. 1.12. What is the ratio of the Amount of imports(as % of merchandise imports) in Manufactures in 1983 to that in 1984?
Your answer should be compact. 0.92. What is the ratio of the Amount of imports(as % of merchandise imports) in Fuel in 1983 to that in 1984?
Ensure brevity in your answer.  1.2. What is the ratio of the Amount of imports(as % of merchandise imports) of Ores and metals in 1983 to that in 1985?
Your answer should be very brief. 1.37. What is the ratio of the Amount of imports(as % of merchandise imports) in Manufactures in 1983 to that in 1985?
Offer a very short reply. 0.87. What is the ratio of the Amount of imports(as % of merchandise imports) in Fuel in 1983 to that in 1985?
Your response must be concise. 1.44. What is the ratio of the Amount of imports(as % of merchandise imports) of Ores and metals in 1983 to that in 1986?
Offer a terse response. 1.35. What is the ratio of the Amount of imports(as % of merchandise imports) in Manufactures in 1983 to that in 1986?
Give a very brief answer. 0.81. What is the ratio of the Amount of imports(as % of merchandise imports) in Fuel in 1983 to that in 1986?
Your response must be concise. 2.15. What is the ratio of the Amount of imports(as % of merchandise imports) in Ores and metals in 1983 to that in 1987?
Provide a succinct answer. 1.46. What is the ratio of the Amount of imports(as % of merchandise imports) of Manufactures in 1983 to that in 1987?
Ensure brevity in your answer.  0.81. What is the ratio of the Amount of imports(as % of merchandise imports) in Fuel in 1983 to that in 1987?
Provide a short and direct response. 2.02. What is the ratio of the Amount of imports(as % of merchandise imports) in Ores and metals in 1983 to that in 1988?
Provide a succinct answer. 1.24. What is the ratio of the Amount of imports(as % of merchandise imports) in Manufactures in 1983 to that in 1988?
Your response must be concise. 0.8. What is the ratio of the Amount of imports(as % of merchandise imports) of Fuel in 1983 to that in 1988?
Your response must be concise. 2.33. What is the ratio of the Amount of imports(as % of merchandise imports) in Ores and metals in 1983 to that in 1989?
Keep it short and to the point. 1.22. What is the ratio of the Amount of imports(as % of merchandise imports) in Manufactures in 1983 to that in 1989?
Provide a short and direct response. 0.82. What is the ratio of the Amount of imports(as % of merchandise imports) of Fuel in 1983 to that in 1989?
Provide a succinct answer. 1.97. What is the ratio of the Amount of imports(as % of merchandise imports) in Ores and metals in 1983 to that in 1990?
Make the answer very short. 1.36. What is the ratio of the Amount of imports(as % of merchandise imports) of Manufactures in 1983 to that in 1990?
Your response must be concise. 0.84. What is the ratio of the Amount of imports(as % of merchandise imports) of Fuel in 1983 to that in 1990?
Make the answer very short. 1.69. What is the ratio of the Amount of imports(as % of merchandise imports) of Ores and metals in 1983 to that in 1991?
Make the answer very short. 1.54. What is the ratio of the Amount of imports(as % of merchandise imports) in Manufactures in 1983 to that in 1991?
Provide a short and direct response. 0.81. What is the ratio of the Amount of imports(as % of merchandise imports) of Fuel in 1983 to that in 1991?
Keep it short and to the point. 1.95. What is the ratio of the Amount of imports(as % of merchandise imports) in Ores and metals in 1984 to that in 1985?
Give a very brief answer. 1.22. What is the ratio of the Amount of imports(as % of merchandise imports) of Manufactures in 1984 to that in 1985?
Your answer should be compact. 0.95. What is the ratio of the Amount of imports(as % of merchandise imports) of Fuel in 1984 to that in 1985?
Offer a very short reply. 1.2. What is the ratio of the Amount of imports(as % of merchandise imports) of Ores and metals in 1984 to that in 1986?
Provide a short and direct response. 1.21. What is the ratio of the Amount of imports(as % of merchandise imports) in Manufactures in 1984 to that in 1986?
Keep it short and to the point. 0.88. What is the ratio of the Amount of imports(as % of merchandise imports) of Fuel in 1984 to that in 1986?
Provide a succinct answer. 1.79. What is the ratio of the Amount of imports(as % of merchandise imports) in Ores and metals in 1984 to that in 1987?
Ensure brevity in your answer.  1.31. What is the ratio of the Amount of imports(as % of merchandise imports) in Manufactures in 1984 to that in 1987?
Make the answer very short. 0.88. What is the ratio of the Amount of imports(as % of merchandise imports) in Fuel in 1984 to that in 1987?
Your response must be concise. 1.69. What is the ratio of the Amount of imports(as % of merchandise imports) in Ores and metals in 1984 to that in 1988?
Keep it short and to the point. 1.11. What is the ratio of the Amount of imports(as % of merchandise imports) of Manufactures in 1984 to that in 1988?
Your response must be concise. 0.87. What is the ratio of the Amount of imports(as % of merchandise imports) in Fuel in 1984 to that in 1988?
Ensure brevity in your answer.  1.94. What is the ratio of the Amount of imports(as % of merchandise imports) of Ores and metals in 1984 to that in 1989?
Your answer should be very brief. 1.09. What is the ratio of the Amount of imports(as % of merchandise imports) of Manufactures in 1984 to that in 1989?
Keep it short and to the point. 0.89. What is the ratio of the Amount of imports(as % of merchandise imports) of Fuel in 1984 to that in 1989?
Offer a terse response. 1.64. What is the ratio of the Amount of imports(as % of merchandise imports) of Ores and metals in 1984 to that in 1990?
Make the answer very short. 1.22. What is the ratio of the Amount of imports(as % of merchandise imports) in Manufactures in 1984 to that in 1990?
Ensure brevity in your answer.  0.91. What is the ratio of the Amount of imports(as % of merchandise imports) of Fuel in 1984 to that in 1990?
Keep it short and to the point. 1.41. What is the ratio of the Amount of imports(as % of merchandise imports) of Ores and metals in 1984 to that in 1991?
Offer a very short reply. 1.38. What is the ratio of the Amount of imports(as % of merchandise imports) of Manufactures in 1984 to that in 1991?
Give a very brief answer. 0.88. What is the ratio of the Amount of imports(as % of merchandise imports) in Fuel in 1984 to that in 1991?
Provide a succinct answer. 1.63. What is the ratio of the Amount of imports(as % of merchandise imports) of Ores and metals in 1985 to that in 1986?
Offer a terse response. 0.99. What is the ratio of the Amount of imports(as % of merchandise imports) of Manufactures in 1985 to that in 1986?
Make the answer very short. 0.93. What is the ratio of the Amount of imports(as % of merchandise imports) in Fuel in 1985 to that in 1986?
Offer a terse response. 1.49. What is the ratio of the Amount of imports(as % of merchandise imports) in Ores and metals in 1985 to that in 1987?
Your answer should be very brief. 1.07. What is the ratio of the Amount of imports(as % of merchandise imports) in Manufactures in 1985 to that in 1987?
Keep it short and to the point. 0.93. What is the ratio of the Amount of imports(as % of merchandise imports) in Fuel in 1985 to that in 1987?
Offer a very short reply. 1.4. What is the ratio of the Amount of imports(as % of merchandise imports) in Ores and metals in 1985 to that in 1988?
Offer a very short reply. 0.91. What is the ratio of the Amount of imports(as % of merchandise imports) of Manufactures in 1985 to that in 1988?
Ensure brevity in your answer.  0.91. What is the ratio of the Amount of imports(as % of merchandise imports) in Fuel in 1985 to that in 1988?
Offer a very short reply. 1.62. What is the ratio of the Amount of imports(as % of merchandise imports) of Ores and metals in 1985 to that in 1989?
Provide a succinct answer. 0.89. What is the ratio of the Amount of imports(as % of merchandise imports) of Manufactures in 1985 to that in 1989?
Your answer should be compact. 0.94. What is the ratio of the Amount of imports(as % of merchandise imports) in Fuel in 1985 to that in 1989?
Offer a very short reply. 1.37. What is the ratio of the Amount of imports(as % of merchandise imports) of Ores and metals in 1985 to that in 1990?
Provide a short and direct response. 1. What is the ratio of the Amount of imports(as % of merchandise imports) in Manufactures in 1985 to that in 1990?
Offer a terse response. 0.96. What is the ratio of the Amount of imports(as % of merchandise imports) in Fuel in 1985 to that in 1990?
Offer a terse response. 1.17. What is the ratio of the Amount of imports(as % of merchandise imports) of Ores and metals in 1985 to that in 1991?
Your answer should be compact. 1.13. What is the ratio of the Amount of imports(as % of merchandise imports) in Manufactures in 1985 to that in 1991?
Provide a short and direct response. 0.93. What is the ratio of the Amount of imports(as % of merchandise imports) in Fuel in 1985 to that in 1991?
Your answer should be very brief. 1.35. What is the ratio of the Amount of imports(as % of merchandise imports) of Ores and metals in 1986 to that in 1987?
Keep it short and to the point. 1.09. What is the ratio of the Amount of imports(as % of merchandise imports) of Manufactures in 1986 to that in 1987?
Provide a short and direct response. 1. What is the ratio of the Amount of imports(as % of merchandise imports) of Fuel in 1986 to that in 1987?
Ensure brevity in your answer.  0.94. What is the ratio of the Amount of imports(as % of merchandise imports) of Manufactures in 1986 to that in 1988?
Offer a very short reply. 0.98. What is the ratio of the Amount of imports(as % of merchandise imports) of Fuel in 1986 to that in 1988?
Your answer should be very brief. 1.09. What is the ratio of the Amount of imports(as % of merchandise imports) of Ores and metals in 1986 to that in 1989?
Provide a short and direct response. 0.91. What is the ratio of the Amount of imports(as % of merchandise imports) in Manufactures in 1986 to that in 1989?
Give a very brief answer. 1. What is the ratio of the Amount of imports(as % of merchandise imports) of Fuel in 1986 to that in 1989?
Ensure brevity in your answer.  0.92. What is the ratio of the Amount of imports(as % of merchandise imports) in Ores and metals in 1986 to that in 1990?
Your answer should be very brief. 1.01. What is the ratio of the Amount of imports(as % of merchandise imports) of Manufactures in 1986 to that in 1990?
Provide a succinct answer. 1.03. What is the ratio of the Amount of imports(as % of merchandise imports) of Fuel in 1986 to that in 1990?
Your answer should be very brief. 0.79. What is the ratio of the Amount of imports(as % of merchandise imports) of Ores and metals in 1986 to that in 1991?
Ensure brevity in your answer.  1.15. What is the ratio of the Amount of imports(as % of merchandise imports) of Fuel in 1986 to that in 1991?
Keep it short and to the point. 0.91. What is the ratio of the Amount of imports(as % of merchandise imports) of Ores and metals in 1987 to that in 1988?
Your answer should be compact. 0.85. What is the ratio of the Amount of imports(as % of merchandise imports) in Manufactures in 1987 to that in 1988?
Provide a succinct answer. 0.98. What is the ratio of the Amount of imports(as % of merchandise imports) of Fuel in 1987 to that in 1988?
Offer a very short reply. 1.15. What is the ratio of the Amount of imports(as % of merchandise imports) in Ores and metals in 1987 to that in 1989?
Your answer should be very brief. 0.83. What is the ratio of the Amount of imports(as % of merchandise imports) of Manufactures in 1987 to that in 1989?
Make the answer very short. 1. What is the ratio of the Amount of imports(as % of merchandise imports) of Fuel in 1987 to that in 1989?
Keep it short and to the point. 0.97. What is the ratio of the Amount of imports(as % of merchandise imports) in Ores and metals in 1987 to that in 1990?
Make the answer very short. 0.93. What is the ratio of the Amount of imports(as % of merchandise imports) of Manufactures in 1987 to that in 1990?
Your response must be concise. 1.03. What is the ratio of the Amount of imports(as % of merchandise imports) in Fuel in 1987 to that in 1990?
Offer a very short reply. 0.83. What is the ratio of the Amount of imports(as % of merchandise imports) of Ores and metals in 1987 to that in 1991?
Provide a succinct answer. 1.06. What is the ratio of the Amount of imports(as % of merchandise imports) in Fuel in 1987 to that in 1991?
Your answer should be very brief. 0.96. What is the ratio of the Amount of imports(as % of merchandise imports) in Ores and metals in 1988 to that in 1989?
Provide a succinct answer. 0.98. What is the ratio of the Amount of imports(as % of merchandise imports) of Manufactures in 1988 to that in 1989?
Provide a short and direct response. 1.02. What is the ratio of the Amount of imports(as % of merchandise imports) in Fuel in 1988 to that in 1989?
Provide a short and direct response. 0.85. What is the ratio of the Amount of imports(as % of merchandise imports) in Ores and metals in 1988 to that in 1990?
Offer a terse response. 1.1. What is the ratio of the Amount of imports(as % of merchandise imports) of Manufactures in 1988 to that in 1990?
Ensure brevity in your answer.  1.05. What is the ratio of the Amount of imports(as % of merchandise imports) in Fuel in 1988 to that in 1990?
Offer a terse response. 0.72. What is the ratio of the Amount of imports(as % of merchandise imports) of Ores and metals in 1988 to that in 1991?
Keep it short and to the point. 1.24. What is the ratio of the Amount of imports(as % of merchandise imports) in Manufactures in 1988 to that in 1991?
Provide a short and direct response. 1.02. What is the ratio of the Amount of imports(as % of merchandise imports) in Fuel in 1988 to that in 1991?
Give a very brief answer. 0.84. What is the ratio of the Amount of imports(as % of merchandise imports) of Ores and metals in 1989 to that in 1990?
Make the answer very short. 1.12. What is the ratio of the Amount of imports(as % of merchandise imports) of Manufactures in 1989 to that in 1990?
Your answer should be compact. 1.03. What is the ratio of the Amount of imports(as % of merchandise imports) in Fuel in 1989 to that in 1990?
Keep it short and to the point. 0.86. What is the ratio of the Amount of imports(as % of merchandise imports) in Ores and metals in 1989 to that in 1991?
Offer a very short reply. 1.27. What is the ratio of the Amount of imports(as % of merchandise imports) in Fuel in 1989 to that in 1991?
Give a very brief answer. 0.99. What is the ratio of the Amount of imports(as % of merchandise imports) in Ores and metals in 1990 to that in 1991?
Give a very brief answer. 1.13. What is the ratio of the Amount of imports(as % of merchandise imports) of Manufactures in 1990 to that in 1991?
Ensure brevity in your answer.  0.97. What is the ratio of the Amount of imports(as % of merchandise imports) in Fuel in 1990 to that in 1991?
Offer a very short reply. 1.16. What is the difference between the highest and the second highest Amount of imports(as % of merchandise imports) of Ores and metals?
Make the answer very short. 0.4. What is the difference between the highest and the second highest Amount of imports(as % of merchandise imports) in Manufactures?
Ensure brevity in your answer.  1.51. What is the difference between the highest and the second highest Amount of imports(as % of merchandise imports) in Fuel?
Make the answer very short. 3.74. What is the difference between the highest and the lowest Amount of imports(as % of merchandise imports) in Ores and metals?
Give a very brief answer. 1.35. What is the difference between the highest and the lowest Amount of imports(as % of merchandise imports) in Manufactures?
Your response must be concise. 15.5. What is the difference between the highest and the lowest Amount of imports(as % of merchandise imports) of Fuel?
Ensure brevity in your answer.  12.78. 